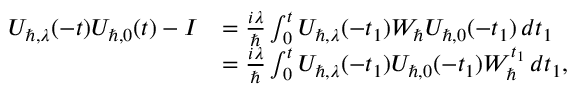<formula> <loc_0><loc_0><loc_500><loc_500>\begin{array} { r l } { U _ { \hbar { , } \lambda } ( - t ) U _ { \hbar { , } 0 } ( t ) - I } & { = \frac { i \lambda } { } \int _ { 0 } ^ { t } U _ { \hbar { , } \lambda } ( - t _ { 1 } ) W _ { } U _ { \hbar { , } 0 } ( - t _ { 1 } ) \, d t _ { 1 } } \\ & { = \frac { i \lambda } { } \int _ { 0 } ^ { t } U _ { \hbar { , } \lambda } ( - t _ { 1 } ) U _ { \hbar { , } 0 } ( - t _ { 1 } ) W _ { } ^ { t _ { 1 } } \, d t _ { 1 } , } \end{array}</formula> 